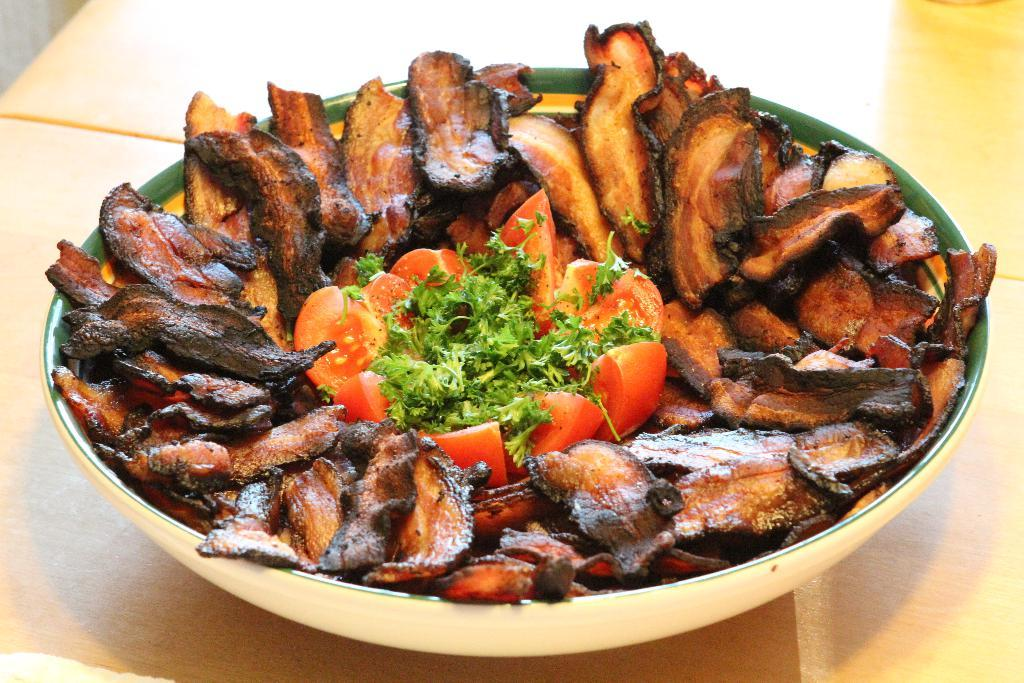What type of table is in the image? There is a wooden table in the image. What is on the table in the image? There is a bowl with food items on the table. What type of pen is visible on the table in the image? There is no pen visible on the table in the image. What journey is being depicted in the image? The image does not depict any journey; it features a wooden table with a bowl of food items. 